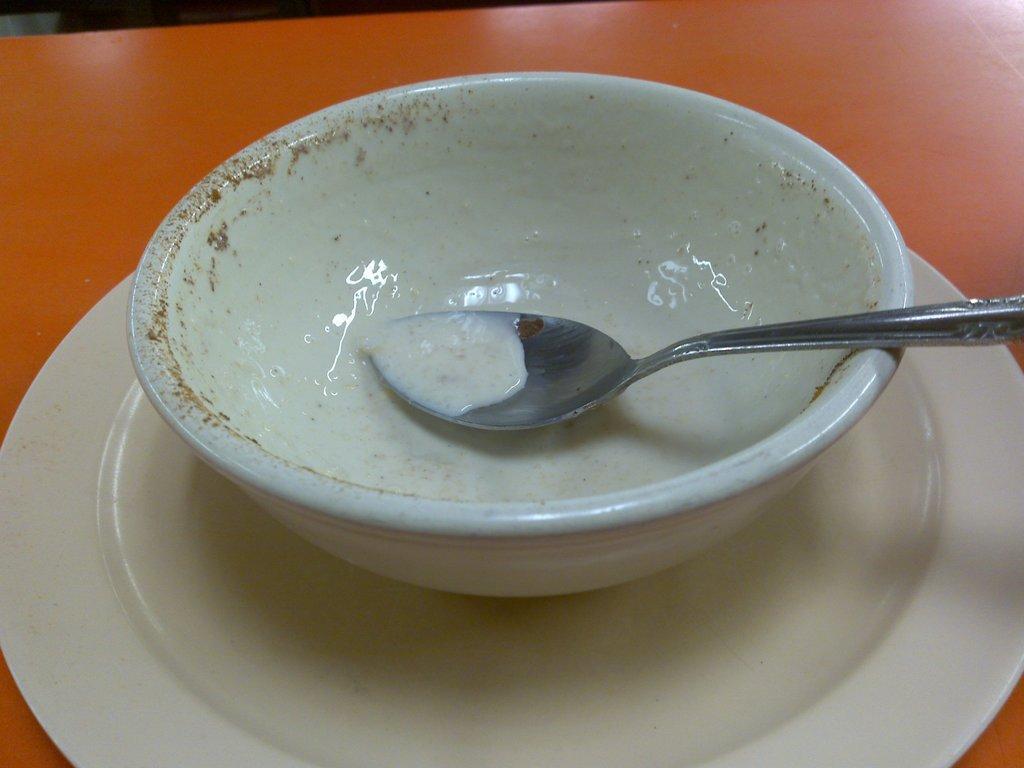Could you give a brief overview of what you see in this image? In this picture we can see the table on it, we can see plate, cup and spoon. 